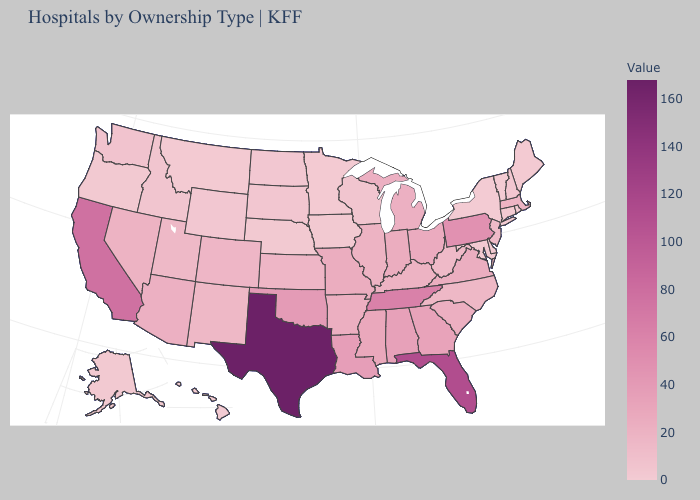Does New Mexico have the lowest value in the USA?
Be succinct. No. Among the states that border Arizona , which have the highest value?
Write a very short answer. California. Which states have the highest value in the USA?
Quick response, please. Texas. Which states have the lowest value in the South?
Write a very short answer. Delaware. Among the states that border Texas , does Oklahoma have the highest value?
Quick response, please. Yes. Does North Dakota have the highest value in the MidWest?
Write a very short answer. No. Which states have the highest value in the USA?
Answer briefly. Texas. Does Alaska have the lowest value in the USA?
Concise answer only. No. Is the legend a continuous bar?
Write a very short answer. Yes. 